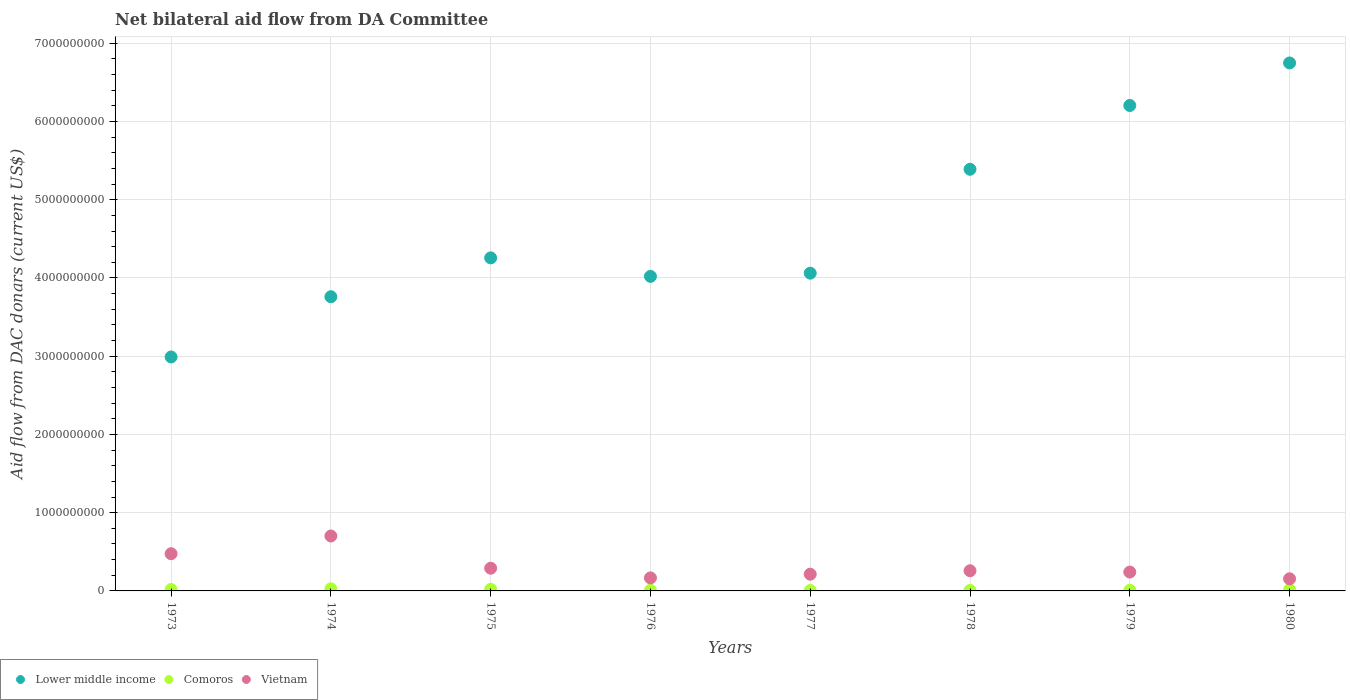How many different coloured dotlines are there?
Your response must be concise. 3. What is the aid flow in in Lower middle income in 1980?
Offer a terse response. 6.75e+09. Across all years, what is the maximum aid flow in in Vietnam?
Offer a very short reply. 7.02e+08. Across all years, what is the minimum aid flow in in Comoros?
Provide a succinct answer. 5.31e+06. In which year was the aid flow in in Vietnam maximum?
Make the answer very short. 1974. What is the total aid flow in in Vietnam in the graph?
Offer a very short reply. 2.50e+09. What is the difference between the aid flow in in Comoros in 1973 and that in 1974?
Your response must be concise. -9.69e+06. What is the difference between the aid flow in in Vietnam in 1973 and the aid flow in in Lower middle income in 1980?
Ensure brevity in your answer.  -6.27e+09. What is the average aid flow in in Vietnam per year?
Give a very brief answer. 3.13e+08. In the year 1976, what is the difference between the aid flow in in Vietnam and aid flow in in Lower middle income?
Provide a succinct answer. -3.85e+09. What is the ratio of the aid flow in in Lower middle income in 1973 to that in 1979?
Keep it short and to the point. 0.48. Is the difference between the aid flow in in Vietnam in 1975 and 1979 greater than the difference between the aid flow in in Lower middle income in 1975 and 1979?
Your answer should be very brief. Yes. What is the difference between the highest and the second highest aid flow in in Lower middle income?
Offer a very short reply. 5.44e+08. What is the difference between the highest and the lowest aid flow in in Comoros?
Make the answer very short. 2.19e+07. Is the sum of the aid flow in in Comoros in 1976 and 1977 greater than the maximum aid flow in in Lower middle income across all years?
Your response must be concise. No. Does the aid flow in in Lower middle income monotonically increase over the years?
Your answer should be compact. No. Is the aid flow in in Comoros strictly greater than the aid flow in in Vietnam over the years?
Provide a short and direct response. No. Is the aid flow in in Comoros strictly less than the aid flow in in Vietnam over the years?
Make the answer very short. Yes. How many dotlines are there?
Provide a short and direct response. 3. How many years are there in the graph?
Your response must be concise. 8. Are the values on the major ticks of Y-axis written in scientific E-notation?
Offer a terse response. No. Does the graph contain any zero values?
Make the answer very short. No. Does the graph contain grids?
Your answer should be compact. Yes. Where does the legend appear in the graph?
Offer a very short reply. Bottom left. How many legend labels are there?
Make the answer very short. 3. How are the legend labels stacked?
Make the answer very short. Horizontal. What is the title of the graph?
Provide a short and direct response. Net bilateral aid flow from DA Committee. What is the label or title of the X-axis?
Keep it short and to the point. Years. What is the label or title of the Y-axis?
Provide a short and direct response. Aid flow from DAC donars (current US$). What is the Aid flow from DAC donars (current US$) in Lower middle income in 1973?
Keep it short and to the point. 2.99e+09. What is the Aid flow from DAC donars (current US$) of Comoros in 1973?
Provide a succinct answer. 1.75e+07. What is the Aid flow from DAC donars (current US$) in Vietnam in 1973?
Offer a very short reply. 4.76e+08. What is the Aid flow from DAC donars (current US$) in Lower middle income in 1974?
Your answer should be compact. 3.76e+09. What is the Aid flow from DAC donars (current US$) in Comoros in 1974?
Offer a terse response. 2.72e+07. What is the Aid flow from DAC donars (current US$) of Vietnam in 1974?
Your answer should be very brief. 7.02e+08. What is the Aid flow from DAC donars (current US$) of Lower middle income in 1975?
Your response must be concise. 4.26e+09. What is the Aid flow from DAC donars (current US$) in Comoros in 1975?
Offer a very short reply. 2.10e+07. What is the Aid flow from DAC donars (current US$) of Vietnam in 1975?
Make the answer very short. 2.90e+08. What is the Aid flow from DAC donars (current US$) of Lower middle income in 1976?
Your response must be concise. 4.02e+09. What is the Aid flow from DAC donars (current US$) in Comoros in 1976?
Your answer should be compact. 9.35e+06. What is the Aid flow from DAC donars (current US$) in Vietnam in 1976?
Give a very brief answer. 1.67e+08. What is the Aid flow from DAC donars (current US$) of Lower middle income in 1977?
Your response must be concise. 4.06e+09. What is the Aid flow from DAC donars (current US$) of Comoros in 1977?
Your response must be concise. 5.31e+06. What is the Aid flow from DAC donars (current US$) of Vietnam in 1977?
Your answer should be very brief. 2.14e+08. What is the Aid flow from DAC donars (current US$) of Lower middle income in 1978?
Your response must be concise. 5.39e+09. What is the Aid flow from DAC donars (current US$) in Comoros in 1978?
Make the answer very short. 5.73e+06. What is the Aid flow from DAC donars (current US$) of Vietnam in 1978?
Ensure brevity in your answer.  2.58e+08. What is the Aid flow from DAC donars (current US$) in Lower middle income in 1979?
Make the answer very short. 6.20e+09. What is the Aid flow from DAC donars (current US$) of Comoros in 1979?
Provide a short and direct response. 8.47e+06. What is the Aid flow from DAC donars (current US$) in Vietnam in 1979?
Provide a short and direct response. 2.41e+08. What is the Aid flow from DAC donars (current US$) in Lower middle income in 1980?
Your answer should be very brief. 6.75e+09. What is the Aid flow from DAC donars (current US$) in Comoros in 1980?
Give a very brief answer. 1.65e+07. What is the Aid flow from DAC donars (current US$) of Vietnam in 1980?
Make the answer very short. 1.55e+08. Across all years, what is the maximum Aid flow from DAC donars (current US$) in Lower middle income?
Offer a very short reply. 6.75e+09. Across all years, what is the maximum Aid flow from DAC donars (current US$) of Comoros?
Provide a succinct answer. 2.72e+07. Across all years, what is the maximum Aid flow from DAC donars (current US$) in Vietnam?
Provide a succinct answer. 7.02e+08. Across all years, what is the minimum Aid flow from DAC donars (current US$) in Lower middle income?
Keep it short and to the point. 2.99e+09. Across all years, what is the minimum Aid flow from DAC donars (current US$) in Comoros?
Provide a short and direct response. 5.31e+06. Across all years, what is the minimum Aid flow from DAC donars (current US$) of Vietnam?
Your answer should be compact. 1.55e+08. What is the total Aid flow from DAC donars (current US$) of Lower middle income in the graph?
Keep it short and to the point. 3.74e+1. What is the total Aid flow from DAC donars (current US$) in Comoros in the graph?
Your answer should be compact. 1.11e+08. What is the total Aid flow from DAC donars (current US$) of Vietnam in the graph?
Keep it short and to the point. 2.50e+09. What is the difference between the Aid flow from DAC donars (current US$) in Lower middle income in 1973 and that in 1974?
Provide a succinct answer. -7.70e+08. What is the difference between the Aid flow from DAC donars (current US$) of Comoros in 1973 and that in 1974?
Provide a succinct answer. -9.69e+06. What is the difference between the Aid flow from DAC donars (current US$) of Vietnam in 1973 and that in 1974?
Give a very brief answer. -2.26e+08. What is the difference between the Aid flow from DAC donars (current US$) in Lower middle income in 1973 and that in 1975?
Make the answer very short. -1.27e+09. What is the difference between the Aid flow from DAC donars (current US$) of Comoros in 1973 and that in 1975?
Provide a short and direct response. -3.48e+06. What is the difference between the Aid flow from DAC donars (current US$) of Vietnam in 1973 and that in 1975?
Offer a terse response. 1.85e+08. What is the difference between the Aid flow from DAC donars (current US$) in Lower middle income in 1973 and that in 1976?
Ensure brevity in your answer.  -1.03e+09. What is the difference between the Aid flow from DAC donars (current US$) of Comoros in 1973 and that in 1976?
Give a very brief answer. 8.17e+06. What is the difference between the Aid flow from DAC donars (current US$) of Vietnam in 1973 and that in 1976?
Make the answer very short. 3.09e+08. What is the difference between the Aid flow from DAC donars (current US$) in Lower middle income in 1973 and that in 1977?
Your response must be concise. -1.07e+09. What is the difference between the Aid flow from DAC donars (current US$) in Comoros in 1973 and that in 1977?
Provide a succinct answer. 1.22e+07. What is the difference between the Aid flow from DAC donars (current US$) of Vietnam in 1973 and that in 1977?
Provide a succinct answer. 2.62e+08. What is the difference between the Aid flow from DAC donars (current US$) of Lower middle income in 1973 and that in 1978?
Give a very brief answer. -2.40e+09. What is the difference between the Aid flow from DAC donars (current US$) of Comoros in 1973 and that in 1978?
Your response must be concise. 1.18e+07. What is the difference between the Aid flow from DAC donars (current US$) in Vietnam in 1973 and that in 1978?
Provide a short and direct response. 2.18e+08. What is the difference between the Aid flow from DAC donars (current US$) in Lower middle income in 1973 and that in 1979?
Give a very brief answer. -3.21e+09. What is the difference between the Aid flow from DAC donars (current US$) of Comoros in 1973 and that in 1979?
Ensure brevity in your answer.  9.05e+06. What is the difference between the Aid flow from DAC donars (current US$) in Vietnam in 1973 and that in 1979?
Your answer should be very brief. 2.35e+08. What is the difference between the Aid flow from DAC donars (current US$) of Lower middle income in 1973 and that in 1980?
Keep it short and to the point. -3.76e+09. What is the difference between the Aid flow from DAC donars (current US$) in Comoros in 1973 and that in 1980?
Give a very brief answer. 1.04e+06. What is the difference between the Aid flow from DAC donars (current US$) of Vietnam in 1973 and that in 1980?
Your answer should be very brief. 3.21e+08. What is the difference between the Aid flow from DAC donars (current US$) in Lower middle income in 1974 and that in 1975?
Make the answer very short. -4.97e+08. What is the difference between the Aid flow from DAC donars (current US$) of Comoros in 1974 and that in 1975?
Give a very brief answer. 6.21e+06. What is the difference between the Aid flow from DAC donars (current US$) in Vietnam in 1974 and that in 1975?
Give a very brief answer. 4.12e+08. What is the difference between the Aid flow from DAC donars (current US$) in Lower middle income in 1974 and that in 1976?
Keep it short and to the point. -2.60e+08. What is the difference between the Aid flow from DAC donars (current US$) of Comoros in 1974 and that in 1976?
Provide a succinct answer. 1.79e+07. What is the difference between the Aid flow from DAC donars (current US$) in Vietnam in 1974 and that in 1976?
Ensure brevity in your answer.  5.36e+08. What is the difference between the Aid flow from DAC donars (current US$) of Lower middle income in 1974 and that in 1977?
Offer a very short reply. -3.01e+08. What is the difference between the Aid flow from DAC donars (current US$) of Comoros in 1974 and that in 1977?
Your answer should be very brief. 2.19e+07. What is the difference between the Aid flow from DAC donars (current US$) of Vietnam in 1974 and that in 1977?
Make the answer very short. 4.88e+08. What is the difference between the Aid flow from DAC donars (current US$) of Lower middle income in 1974 and that in 1978?
Your answer should be compact. -1.63e+09. What is the difference between the Aid flow from DAC donars (current US$) in Comoros in 1974 and that in 1978?
Your answer should be very brief. 2.15e+07. What is the difference between the Aid flow from DAC donars (current US$) in Vietnam in 1974 and that in 1978?
Keep it short and to the point. 4.44e+08. What is the difference between the Aid flow from DAC donars (current US$) in Lower middle income in 1974 and that in 1979?
Ensure brevity in your answer.  -2.44e+09. What is the difference between the Aid flow from DAC donars (current US$) in Comoros in 1974 and that in 1979?
Make the answer very short. 1.87e+07. What is the difference between the Aid flow from DAC donars (current US$) in Vietnam in 1974 and that in 1979?
Your answer should be very brief. 4.61e+08. What is the difference between the Aid flow from DAC donars (current US$) of Lower middle income in 1974 and that in 1980?
Give a very brief answer. -2.99e+09. What is the difference between the Aid flow from DAC donars (current US$) in Comoros in 1974 and that in 1980?
Ensure brevity in your answer.  1.07e+07. What is the difference between the Aid flow from DAC donars (current US$) of Vietnam in 1974 and that in 1980?
Ensure brevity in your answer.  5.47e+08. What is the difference between the Aid flow from DAC donars (current US$) in Lower middle income in 1975 and that in 1976?
Your response must be concise. 2.36e+08. What is the difference between the Aid flow from DAC donars (current US$) in Comoros in 1975 and that in 1976?
Your answer should be very brief. 1.16e+07. What is the difference between the Aid flow from DAC donars (current US$) in Vietnam in 1975 and that in 1976?
Offer a terse response. 1.24e+08. What is the difference between the Aid flow from DAC donars (current US$) in Lower middle income in 1975 and that in 1977?
Your response must be concise. 1.96e+08. What is the difference between the Aid flow from DAC donars (current US$) of Comoros in 1975 and that in 1977?
Your response must be concise. 1.57e+07. What is the difference between the Aid flow from DAC donars (current US$) of Vietnam in 1975 and that in 1977?
Offer a very short reply. 7.63e+07. What is the difference between the Aid flow from DAC donars (current US$) in Lower middle income in 1975 and that in 1978?
Your answer should be very brief. -1.13e+09. What is the difference between the Aid flow from DAC donars (current US$) of Comoros in 1975 and that in 1978?
Your answer should be compact. 1.53e+07. What is the difference between the Aid flow from DAC donars (current US$) in Vietnam in 1975 and that in 1978?
Keep it short and to the point. 3.23e+07. What is the difference between the Aid flow from DAC donars (current US$) of Lower middle income in 1975 and that in 1979?
Make the answer very short. -1.95e+09. What is the difference between the Aid flow from DAC donars (current US$) in Comoros in 1975 and that in 1979?
Provide a short and direct response. 1.25e+07. What is the difference between the Aid flow from DAC donars (current US$) of Vietnam in 1975 and that in 1979?
Your answer should be compact. 4.92e+07. What is the difference between the Aid flow from DAC donars (current US$) in Lower middle income in 1975 and that in 1980?
Your answer should be very brief. -2.49e+09. What is the difference between the Aid flow from DAC donars (current US$) of Comoros in 1975 and that in 1980?
Offer a terse response. 4.52e+06. What is the difference between the Aid flow from DAC donars (current US$) of Vietnam in 1975 and that in 1980?
Provide a succinct answer. 1.35e+08. What is the difference between the Aid flow from DAC donars (current US$) of Lower middle income in 1976 and that in 1977?
Your response must be concise. -4.10e+07. What is the difference between the Aid flow from DAC donars (current US$) in Comoros in 1976 and that in 1977?
Give a very brief answer. 4.04e+06. What is the difference between the Aid flow from DAC donars (current US$) of Vietnam in 1976 and that in 1977?
Offer a terse response. -4.73e+07. What is the difference between the Aid flow from DAC donars (current US$) in Lower middle income in 1976 and that in 1978?
Make the answer very short. -1.37e+09. What is the difference between the Aid flow from DAC donars (current US$) in Comoros in 1976 and that in 1978?
Offer a very short reply. 3.62e+06. What is the difference between the Aid flow from DAC donars (current US$) in Vietnam in 1976 and that in 1978?
Make the answer very short. -9.13e+07. What is the difference between the Aid flow from DAC donars (current US$) of Lower middle income in 1976 and that in 1979?
Offer a terse response. -2.18e+09. What is the difference between the Aid flow from DAC donars (current US$) in Comoros in 1976 and that in 1979?
Make the answer very short. 8.80e+05. What is the difference between the Aid flow from DAC donars (current US$) of Vietnam in 1976 and that in 1979?
Provide a succinct answer. -7.44e+07. What is the difference between the Aid flow from DAC donars (current US$) of Lower middle income in 1976 and that in 1980?
Make the answer very short. -2.73e+09. What is the difference between the Aid flow from DAC donars (current US$) of Comoros in 1976 and that in 1980?
Keep it short and to the point. -7.13e+06. What is the difference between the Aid flow from DAC donars (current US$) in Vietnam in 1976 and that in 1980?
Your answer should be very brief. 1.15e+07. What is the difference between the Aid flow from DAC donars (current US$) of Lower middle income in 1977 and that in 1978?
Your answer should be compact. -1.33e+09. What is the difference between the Aid flow from DAC donars (current US$) of Comoros in 1977 and that in 1978?
Offer a terse response. -4.20e+05. What is the difference between the Aid flow from DAC donars (current US$) in Vietnam in 1977 and that in 1978?
Your response must be concise. -4.40e+07. What is the difference between the Aid flow from DAC donars (current US$) of Lower middle income in 1977 and that in 1979?
Your answer should be very brief. -2.14e+09. What is the difference between the Aid flow from DAC donars (current US$) of Comoros in 1977 and that in 1979?
Offer a terse response. -3.16e+06. What is the difference between the Aid flow from DAC donars (current US$) of Vietnam in 1977 and that in 1979?
Make the answer very short. -2.71e+07. What is the difference between the Aid flow from DAC donars (current US$) of Lower middle income in 1977 and that in 1980?
Your answer should be very brief. -2.69e+09. What is the difference between the Aid flow from DAC donars (current US$) of Comoros in 1977 and that in 1980?
Make the answer very short. -1.12e+07. What is the difference between the Aid flow from DAC donars (current US$) in Vietnam in 1977 and that in 1980?
Ensure brevity in your answer.  5.88e+07. What is the difference between the Aid flow from DAC donars (current US$) of Lower middle income in 1978 and that in 1979?
Keep it short and to the point. -8.15e+08. What is the difference between the Aid flow from DAC donars (current US$) of Comoros in 1978 and that in 1979?
Keep it short and to the point. -2.74e+06. What is the difference between the Aid flow from DAC donars (current US$) in Vietnam in 1978 and that in 1979?
Your answer should be compact. 1.69e+07. What is the difference between the Aid flow from DAC donars (current US$) of Lower middle income in 1978 and that in 1980?
Your response must be concise. -1.36e+09. What is the difference between the Aid flow from DAC donars (current US$) in Comoros in 1978 and that in 1980?
Offer a very short reply. -1.08e+07. What is the difference between the Aid flow from DAC donars (current US$) of Vietnam in 1978 and that in 1980?
Ensure brevity in your answer.  1.03e+08. What is the difference between the Aid flow from DAC donars (current US$) of Lower middle income in 1979 and that in 1980?
Offer a very short reply. -5.44e+08. What is the difference between the Aid flow from DAC donars (current US$) in Comoros in 1979 and that in 1980?
Your answer should be very brief. -8.01e+06. What is the difference between the Aid flow from DAC donars (current US$) in Vietnam in 1979 and that in 1980?
Keep it short and to the point. 8.59e+07. What is the difference between the Aid flow from DAC donars (current US$) of Lower middle income in 1973 and the Aid flow from DAC donars (current US$) of Comoros in 1974?
Offer a terse response. 2.96e+09. What is the difference between the Aid flow from DAC donars (current US$) in Lower middle income in 1973 and the Aid flow from DAC donars (current US$) in Vietnam in 1974?
Provide a succinct answer. 2.29e+09. What is the difference between the Aid flow from DAC donars (current US$) of Comoros in 1973 and the Aid flow from DAC donars (current US$) of Vietnam in 1974?
Keep it short and to the point. -6.85e+08. What is the difference between the Aid flow from DAC donars (current US$) in Lower middle income in 1973 and the Aid flow from DAC donars (current US$) in Comoros in 1975?
Your answer should be compact. 2.97e+09. What is the difference between the Aid flow from DAC donars (current US$) in Lower middle income in 1973 and the Aid flow from DAC donars (current US$) in Vietnam in 1975?
Ensure brevity in your answer.  2.70e+09. What is the difference between the Aid flow from DAC donars (current US$) of Comoros in 1973 and the Aid flow from DAC donars (current US$) of Vietnam in 1975?
Ensure brevity in your answer.  -2.73e+08. What is the difference between the Aid flow from DAC donars (current US$) of Lower middle income in 1973 and the Aid flow from DAC donars (current US$) of Comoros in 1976?
Provide a succinct answer. 2.98e+09. What is the difference between the Aid flow from DAC donars (current US$) of Lower middle income in 1973 and the Aid flow from DAC donars (current US$) of Vietnam in 1976?
Ensure brevity in your answer.  2.82e+09. What is the difference between the Aid flow from DAC donars (current US$) in Comoros in 1973 and the Aid flow from DAC donars (current US$) in Vietnam in 1976?
Offer a very short reply. -1.49e+08. What is the difference between the Aid flow from DAC donars (current US$) of Lower middle income in 1973 and the Aid flow from DAC donars (current US$) of Comoros in 1977?
Your response must be concise. 2.98e+09. What is the difference between the Aid flow from DAC donars (current US$) of Lower middle income in 1973 and the Aid flow from DAC donars (current US$) of Vietnam in 1977?
Provide a succinct answer. 2.78e+09. What is the difference between the Aid flow from DAC donars (current US$) of Comoros in 1973 and the Aid flow from DAC donars (current US$) of Vietnam in 1977?
Provide a short and direct response. -1.96e+08. What is the difference between the Aid flow from DAC donars (current US$) of Lower middle income in 1973 and the Aid flow from DAC donars (current US$) of Comoros in 1978?
Offer a very short reply. 2.98e+09. What is the difference between the Aid flow from DAC donars (current US$) of Lower middle income in 1973 and the Aid flow from DAC donars (current US$) of Vietnam in 1978?
Ensure brevity in your answer.  2.73e+09. What is the difference between the Aid flow from DAC donars (current US$) in Comoros in 1973 and the Aid flow from DAC donars (current US$) in Vietnam in 1978?
Offer a very short reply. -2.40e+08. What is the difference between the Aid flow from DAC donars (current US$) of Lower middle income in 1973 and the Aid flow from DAC donars (current US$) of Comoros in 1979?
Your answer should be very brief. 2.98e+09. What is the difference between the Aid flow from DAC donars (current US$) in Lower middle income in 1973 and the Aid flow from DAC donars (current US$) in Vietnam in 1979?
Your answer should be very brief. 2.75e+09. What is the difference between the Aid flow from DAC donars (current US$) in Comoros in 1973 and the Aid flow from DAC donars (current US$) in Vietnam in 1979?
Your answer should be very brief. -2.23e+08. What is the difference between the Aid flow from DAC donars (current US$) in Lower middle income in 1973 and the Aid flow from DAC donars (current US$) in Comoros in 1980?
Make the answer very short. 2.97e+09. What is the difference between the Aid flow from DAC donars (current US$) of Lower middle income in 1973 and the Aid flow from DAC donars (current US$) of Vietnam in 1980?
Give a very brief answer. 2.84e+09. What is the difference between the Aid flow from DAC donars (current US$) in Comoros in 1973 and the Aid flow from DAC donars (current US$) in Vietnam in 1980?
Your answer should be compact. -1.38e+08. What is the difference between the Aid flow from DAC donars (current US$) in Lower middle income in 1974 and the Aid flow from DAC donars (current US$) in Comoros in 1975?
Your response must be concise. 3.74e+09. What is the difference between the Aid flow from DAC donars (current US$) of Lower middle income in 1974 and the Aid flow from DAC donars (current US$) of Vietnam in 1975?
Make the answer very short. 3.47e+09. What is the difference between the Aid flow from DAC donars (current US$) in Comoros in 1974 and the Aid flow from DAC donars (current US$) in Vietnam in 1975?
Keep it short and to the point. -2.63e+08. What is the difference between the Aid flow from DAC donars (current US$) in Lower middle income in 1974 and the Aid flow from DAC donars (current US$) in Comoros in 1976?
Offer a terse response. 3.75e+09. What is the difference between the Aid flow from DAC donars (current US$) of Lower middle income in 1974 and the Aid flow from DAC donars (current US$) of Vietnam in 1976?
Offer a very short reply. 3.59e+09. What is the difference between the Aid flow from DAC donars (current US$) in Comoros in 1974 and the Aid flow from DAC donars (current US$) in Vietnam in 1976?
Ensure brevity in your answer.  -1.39e+08. What is the difference between the Aid flow from DAC donars (current US$) of Lower middle income in 1974 and the Aid flow from DAC donars (current US$) of Comoros in 1977?
Your answer should be compact. 3.75e+09. What is the difference between the Aid flow from DAC donars (current US$) of Lower middle income in 1974 and the Aid flow from DAC donars (current US$) of Vietnam in 1977?
Provide a short and direct response. 3.55e+09. What is the difference between the Aid flow from DAC donars (current US$) in Comoros in 1974 and the Aid flow from DAC donars (current US$) in Vietnam in 1977?
Provide a short and direct response. -1.87e+08. What is the difference between the Aid flow from DAC donars (current US$) in Lower middle income in 1974 and the Aid flow from DAC donars (current US$) in Comoros in 1978?
Make the answer very short. 3.75e+09. What is the difference between the Aid flow from DAC donars (current US$) of Lower middle income in 1974 and the Aid flow from DAC donars (current US$) of Vietnam in 1978?
Keep it short and to the point. 3.50e+09. What is the difference between the Aid flow from DAC donars (current US$) of Comoros in 1974 and the Aid flow from DAC donars (current US$) of Vietnam in 1978?
Your answer should be compact. -2.31e+08. What is the difference between the Aid flow from DAC donars (current US$) in Lower middle income in 1974 and the Aid flow from DAC donars (current US$) in Comoros in 1979?
Your response must be concise. 3.75e+09. What is the difference between the Aid flow from DAC donars (current US$) in Lower middle income in 1974 and the Aid flow from DAC donars (current US$) in Vietnam in 1979?
Your answer should be very brief. 3.52e+09. What is the difference between the Aid flow from DAC donars (current US$) of Comoros in 1974 and the Aid flow from DAC donars (current US$) of Vietnam in 1979?
Keep it short and to the point. -2.14e+08. What is the difference between the Aid flow from DAC donars (current US$) of Lower middle income in 1974 and the Aid flow from DAC donars (current US$) of Comoros in 1980?
Ensure brevity in your answer.  3.74e+09. What is the difference between the Aid flow from DAC donars (current US$) of Lower middle income in 1974 and the Aid flow from DAC donars (current US$) of Vietnam in 1980?
Ensure brevity in your answer.  3.60e+09. What is the difference between the Aid flow from DAC donars (current US$) in Comoros in 1974 and the Aid flow from DAC donars (current US$) in Vietnam in 1980?
Ensure brevity in your answer.  -1.28e+08. What is the difference between the Aid flow from DAC donars (current US$) of Lower middle income in 1975 and the Aid flow from DAC donars (current US$) of Comoros in 1976?
Provide a succinct answer. 4.25e+09. What is the difference between the Aid flow from DAC donars (current US$) of Lower middle income in 1975 and the Aid flow from DAC donars (current US$) of Vietnam in 1976?
Provide a succinct answer. 4.09e+09. What is the difference between the Aid flow from DAC donars (current US$) of Comoros in 1975 and the Aid flow from DAC donars (current US$) of Vietnam in 1976?
Your answer should be very brief. -1.46e+08. What is the difference between the Aid flow from DAC donars (current US$) of Lower middle income in 1975 and the Aid flow from DAC donars (current US$) of Comoros in 1977?
Ensure brevity in your answer.  4.25e+09. What is the difference between the Aid flow from DAC donars (current US$) in Lower middle income in 1975 and the Aid flow from DAC donars (current US$) in Vietnam in 1977?
Offer a very short reply. 4.04e+09. What is the difference between the Aid flow from DAC donars (current US$) in Comoros in 1975 and the Aid flow from DAC donars (current US$) in Vietnam in 1977?
Your response must be concise. -1.93e+08. What is the difference between the Aid flow from DAC donars (current US$) of Lower middle income in 1975 and the Aid flow from DAC donars (current US$) of Comoros in 1978?
Offer a very short reply. 4.25e+09. What is the difference between the Aid flow from DAC donars (current US$) of Lower middle income in 1975 and the Aid flow from DAC donars (current US$) of Vietnam in 1978?
Give a very brief answer. 4.00e+09. What is the difference between the Aid flow from DAC donars (current US$) in Comoros in 1975 and the Aid flow from DAC donars (current US$) in Vietnam in 1978?
Provide a succinct answer. -2.37e+08. What is the difference between the Aid flow from DAC donars (current US$) of Lower middle income in 1975 and the Aid flow from DAC donars (current US$) of Comoros in 1979?
Make the answer very short. 4.25e+09. What is the difference between the Aid flow from DAC donars (current US$) in Lower middle income in 1975 and the Aid flow from DAC donars (current US$) in Vietnam in 1979?
Offer a terse response. 4.02e+09. What is the difference between the Aid flow from DAC donars (current US$) in Comoros in 1975 and the Aid flow from DAC donars (current US$) in Vietnam in 1979?
Provide a succinct answer. -2.20e+08. What is the difference between the Aid flow from DAC donars (current US$) in Lower middle income in 1975 and the Aid flow from DAC donars (current US$) in Comoros in 1980?
Make the answer very short. 4.24e+09. What is the difference between the Aid flow from DAC donars (current US$) of Lower middle income in 1975 and the Aid flow from DAC donars (current US$) of Vietnam in 1980?
Offer a very short reply. 4.10e+09. What is the difference between the Aid flow from DAC donars (current US$) of Comoros in 1975 and the Aid flow from DAC donars (current US$) of Vietnam in 1980?
Offer a terse response. -1.34e+08. What is the difference between the Aid flow from DAC donars (current US$) in Lower middle income in 1976 and the Aid flow from DAC donars (current US$) in Comoros in 1977?
Provide a succinct answer. 4.01e+09. What is the difference between the Aid flow from DAC donars (current US$) in Lower middle income in 1976 and the Aid flow from DAC donars (current US$) in Vietnam in 1977?
Provide a succinct answer. 3.81e+09. What is the difference between the Aid flow from DAC donars (current US$) of Comoros in 1976 and the Aid flow from DAC donars (current US$) of Vietnam in 1977?
Give a very brief answer. -2.05e+08. What is the difference between the Aid flow from DAC donars (current US$) in Lower middle income in 1976 and the Aid flow from DAC donars (current US$) in Comoros in 1978?
Provide a short and direct response. 4.01e+09. What is the difference between the Aid flow from DAC donars (current US$) of Lower middle income in 1976 and the Aid flow from DAC donars (current US$) of Vietnam in 1978?
Give a very brief answer. 3.76e+09. What is the difference between the Aid flow from DAC donars (current US$) in Comoros in 1976 and the Aid flow from DAC donars (current US$) in Vietnam in 1978?
Ensure brevity in your answer.  -2.49e+08. What is the difference between the Aid flow from DAC donars (current US$) in Lower middle income in 1976 and the Aid flow from DAC donars (current US$) in Comoros in 1979?
Provide a succinct answer. 4.01e+09. What is the difference between the Aid flow from DAC donars (current US$) of Lower middle income in 1976 and the Aid flow from DAC donars (current US$) of Vietnam in 1979?
Provide a succinct answer. 3.78e+09. What is the difference between the Aid flow from DAC donars (current US$) in Comoros in 1976 and the Aid flow from DAC donars (current US$) in Vietnam in 1979?
Keep it short and to the point. -2.32e+08. What is the difference between the Aid flow from DAC donars (current US$) in Lower middle income in 1976 and the Aid flow from DAC donars (current US$) in Comoros in 1980?
Make the answer very short. 4.00e+09. What is the difference between the Aid flow from DAC donars (current US$) of Lower middle income in 1976 and the Aid flow from DAC donars (current US$) of Vietnam in 1980?
Keep it short and to the point. 3.86e+09. What is the difference between the Aid flow from DAC donars (current US$) of Comoros in 1976 and the Aid flow from DAC donars (current US$) of Vietnam in 1980?
Your answer should be compact. -1.46e+08. What is the difference between the Aid flow from DAC donars (current US$) in Lower middle income in 1977 and the Aid flow from DAC donars (current US$) in Comoros in 1978?
Your answer should be very brief. 4.06e+09. What is the difference between the Aid flow from DAC donars (current US$) in Lower middle income in 1977 and the Aid flow from DAC donars (current US$) in Vietnam in 1978?
Provide a short and direct response. 3.80e+09. What is the difference between the Aid flow from DAC donars (current US$) in Comoros in 1977 and the Aid flow from DAC donars (current US$) in Vietnam in 1978?
Keep it short and to the point. -2.53e+08. What is the difference between the Aid flow from DAC donars (current US$) of Lower middle income in 1977 and the Aid flow from DAC donars (current US$) of Comoros in 1979?
Offer a very short reply. 4.05e+09. What is the difference between the Aid flow from DAC donars (current US$) of Lower middle income in 1977 and the Aid flow from DAC donars (current US$) of Vietnam in 1979?
Make the answer very short. 3.82e+09. What is the difference between the Aid flow from DAC donars (current US$) of Comoros in 1977 and the Aid flow from DAC donars (current US$) of Vietnam in 1979?
Your answer should be very brief. -2.36e+08. What is the difference between the Aid flow from DAC donars (current US$) of Lower middle income in 1977 and the Aid flow from DAC donars (current US$) of Comoros in 1980?
Give a very brief answer. 4.04e+09. What is the difference between the Aid flow from DAC donars (current US$) of Lower middle income in 1977 and the Aid flow from DAC donars (current US$) of Vietnam in 1980?
Your response must be concise. 3.91e+09. What is the difference between the Aid flow from DAC donars (current US$) in Comoros in 1977 and the Aid flow from DAC donars (current US$) in Vietnam in 1980?
Your answer should be compact. -1.50e+08. What is the difference between the Aid flow from DAC donars (current US$) in Lower middle income in 1978 and the Aid flow from DAC donars (current US$) in Comoros in 1979?
Your response must be concise. 5.38e+09. What is the difference between the Aid flow from DAC donars (current US$) of Lower middle income in 1978 and the Aid flow from DAC donars (current US$) of Vietnam in 1979?
Your answer should be compact. 5.15e+09. What is the difference between the Aid flow from DAC donars (current US$) of Comoros in 1978 and the Aid flow from DAC donars (current US$) of Vietnam in 1979?
Provide a short and direct response. -2.35e+08. What is the difference between the Aid flow from DAC donars (current US$) of Lower middle income in 1978 and the Aid flow from DAC donars (current US$) of Comoros in 1980?
Provide a succinct answer. 5.37e+09. What is the difference between the Aid flow from DAC donars (current US$) of Lower middle income in 1978 and the Aid flow from DAC donars (current US$) of Vietnam in 1980?
Your response must be concise. 5.23e+09. What is the difference between the Aid flow from DAC donars (current US$) in Comoros in 1978 and the Aid flow from DAC donars (current US$) in Vietnam in 1980?
Your response must be concise. -1.49e+08. What is the difference between the Aid flow from DAC donars (current US$) of Lower middle income in 1979 and the Aid flow from DAC donars (current US$) of Comoros in 1980?
Give a very brief answer. 6.19e+09. What is the difference between the Aid flow from DAC donars (current US$) in Lower middle income in 1979 and the Aid flow from DAC donars (current US$) in Vietnam in 1980?
Give a very brief answer. 6.05e+09. What is the difference between the Aid flow from DAC donars (current US$) of Comoros in 1979 and the Aid flow from DAC donars (current US$) of Vietnam in 1980?
Make the answer very short. -1.47e+08. What is the average Aid flow from DAC donars (current US$) of Lower middle income per year?
Your answer should be compact. 4.68e+09. What is the average Aid flow from DAC donars (current US$) in Comoros per year?
Offer a very short reply. 1.39e+07. What is the average Aid flow from DAC donars (current US$) of Vietnam per year?
Provide a short and direct response. 3.13e+08. In the year 1973, what is the difference between the Aid flow from DAC donars (current US$) of Lower middle income and Aid flow from DAC donars (current US$) of Comoros?
Your answer should be compact. 2.97e+09. In the year 1973, what is the difference between the Aid flow from DAC donars (current US$) in Lower middle income and Aid flow from DAC donars (current US$) in Vietnam?
Make the answer very short. 2.51e+09. In the year 1973, what is the difference between the Aid flow from DAC donars (current US$) of Comoros and Aid flow from DAC donars (current US$) of Vietnam?
Give a very brief answer. -4.58e+08. In the year 1974, what is the difference between the Aid flow from DAC donars (current US$) in Lower middle income and Aid flow from DAC donars (current US$) in Comoros?
Keep it short and to the point. 3.73e+09. In the year 1974, what is the difference between the Aid flow from DAC donars (current US$) of Lower middle income and Aid flow from DAC donars (current US$) of Vietnam?
Provide a short and direct response. 3.06e+09. In the year 1974, what is the difference between the Aid flow from DAC donars (current US$) of Comoros and Aid flow from DAC donars (current US$) of Vietnam?
Ensure brevity in your answer.  -6.75e+08. In the year 1975, what is the difference between the Aid flow from DAC donars (current US$) of Lower middle income and Aid flow from DAC donars (current US$) of Comoros?
Your answer should be very brief. 4.24e+09. In the year 1975, what is the difference between the Aid flow from DAC donars (current US$) in Lower middle income and Aid flow from DAC donars (current US$) in Vietnam?
Keep it short and to the point. 3.97e+09. In the year 1975, what is the difference between the Aid flow from DAC donars (current US$) of Comoros and Aid flow from DAC donars (current US$) of Vietnam?
Keep it short and to the point. -2.69e+08. In the year 1976, what is the difference between the Aid flow from DAC donars (current US$) of Lower middle income and Aid flow from DAC donars (current US$) of Comoros?
Give a very brief answer. 4.01e+09. In the year 1976, what is the difference between the Aid flow from DAC donars (current US$) of Lower middle income and Aid flow from DAC donars (current US$) of Vietnam?
Keep it short and to the point. 3.85e+09. In the year 1976, what is the difference between the Aid flow from DAC donars (current US$) in Comoros and Aid flow from DAC donars (current US$) in Vietnam?
Make the answer very short. -1.57e+08. In the year 1977, what is the difference between the Aid flow from DAC donars (current US$) of Lower middle income and Aid flow from DAC donars (current US$) of Comoros?
Your response must be concise. 4.06e+09. In the year 1977, what is the difference between the Aid flow from DAC donars (current US$) of Lower middle income and Aid flow from DAC donars (current US$) of Vietnam?
Your answer should be very brief. 3.85e+09. In the year 1977, what is the difference between the Aid flow from DAC donars (current US$) in Comoros and Aid flow from DAC donars (current US$) in Vietnam?
Ensure brevity in your answer.  -2.09e+08. In the year 1978, what is the difference between the Aid flow from DAC donars (current US$) in Lower middle income and Aid flow from DAC donars (current US$) in Comoros?
Your answer should be very brief. 5.38e+09. In the year 1978, what is the difference between the Aid flow from DAC donars (current US$) of Lower middle income and Aid flow from DAC donars (current US$) of Vietnam?
Your answer should be very brief. 5.13e+09. In the year 1978, what is the difference between the Aid flow from DAC donars (current US$) in Comoros and Aid flow from DAC donars (current US$) in Vietnam?
Make the answer very short. -2.52e+08. In the year 1979, what is the difference between the Aid flow from DAC donars (current US$) in Lower middle income and Aid flow from DAC donars (current US$) in Comoros?
Make the answer very short. 6.20e+09. In the year 1979, what is the difference between the Aid flow from DAC donars (current US$) in Lower middle income and Aid flow from DAC donars (current US$) in Vietnam?
Keep it short and to the point. 5.96e+09. In the year 1979, what is the difference between the Aid flow from DAC donars (current US$) of Comoros and Aid flow from DAC donars (current US$) of Vietnam?
Provide a succinct answer. -2.33e+08. In the year 1980, what is the difference between the Aid flow from DAC donars (current US$) in Lower middle income and Aid flow from DAC donars (current US$) in Comoros?
Make the answer very short. 6.73e+09. In the year 1980, what is the difference between the Aid flow from DAC donars (current US$) in Lower middle income and Aid flow from DAC donars (current US$) in Vietnam?
Your answer should be compact. 6.59e+09. In the year 1980, what is the difference between the Aid flow from DAC donars (current US$) of Comoros and Aid flow from DAC donars (current US$) of Vietnam?
Give a very brief answer. -1.39e+08. What is the ratio of the Aid flow from DAC donars (current US$) of Lower middle income in 1973 to that in 1974?
Keep it short and to the point. 0.8. What is the ratio of the Aid flow from DAC donars (current US$) in Comoros in 1973 to that in 1974?
Your answer should be compact. 0.64. What is the ratio of the Aid flow from DAC donars (current US$) in Vietnam in 1973 to that in 1974?
Your answer should be compact. 0.68. What is the ratio of the Aid flow from DAC donars (current US$) in Lower middle income in 1973 to that in 1975?
Keep it short and to the point. 0.7. What is the ratio of the Aid flow from DAC donars (current US$) of Comoros in 1973 to that in 1975?
Provide a succinct answer. 0.83. What is the ratio of the Aid flow from DAC donars (current US$) of Vietnam in 1973 to that in 1975?
Give a very brief answer. 1.64. What is the ratio of the Aid flow from DAC donars (current US$) of Lower middle income in 1973 to that in 1976?
Ensure brevity in your answer.  0.74. What is the ratio of the Aid flow from DAC donars (current US$) in Comoros in 1973 to that in 1976?
Offer a terse response. 1.87. What is the ratio of the Aid flow from DAC donars (current US$) in Vietnam in 1973 to that in 1976?
Your answer should be very brief. 2.86. What is the ratio of the Aid flow from DAC donars (current US$) in Lower middle income in 1973 to that in 1977?
Give a very brief answer. 0.74. What is the ratio of the Aid flow from DAC donars (current US$) of Comoros in 1973 to that in 1977?
Provide a succinct answer. 3.3. What is the ratio of the Aid flow from DAC donars (current US$) in Vietnam in 1973 to that in 1977?
Your answer should be compact. 2.22. What is the ratio of the Aid flow from DAC donars (current US$) in Lower middle income in 1973 to that in 1978?
Your response must be concise. 0.55. What is the ratio of the Aid flow from DAC donars (current US$) of Comoros in 1973 to that in 1978?
Offer a terse response. 3.06. What is the ratio of the Aid flow from DAC donars (current US$) of Vietnam in 1973 to that in 1978?
Give a very brief answer. 1.84. What is the ratio of the Aid flow from DAC donars (current US$) in Lower middle income in 1973 to that in 1979?
Offer a terse response. 0.48. What is the ratio of the Aid flow from DAC donars (current US$) of Comoros in 1973 to that in 1979?
Give a very brief answer. 2.07. What is the ratio of the Aid flow from DAC donars (current US$) in Vietnam in 1973 to that in 1979?
Offer a very short reply. 1.97. What is the ratio of the Aid flow from DAC donars (current US$) in Lower middle income in 1973 to that in 1980?
Keep it short and to the point. 0.44. What is the ratio of the Aid flow from DAC donars (current US$) in Comoros in 1973 to that in 1980?
Give a very brief answer. 1.06. What is the ratio of the Aid flow from DAC donars (current US$) of Vietnam in 1973 to that in 1980?
Your response must be concise. 3.07. What is the ratio of the Aid flow from DAC donars (current US$) in Lower middle income in 1974 to that in 1975?
Ensure brevity in your answer.  0.88. What is the ratio of the Aid flow from DAC donars (current US$) of Comoros in 1974 to that in 1975?
Ensure brevity in your answer.  1.3. What is the ratio of the Aid flow from DAC donars (current US$) of Vietnam in 1974 to that in 1975?
Your response must be concise. 2.42. What is the ratio of the Aid flow from DAC donars (current US$) of Lower middle income in 1974 to that in 1976?
Your answer should be compact. 0.94. What is the ratio of the Aid flow from DAC donars (current US$) of Comoros in 1974 to that in 1976?
Make the answer very short. 2.91. What is the ratio of the Aid flow from DAC donars (current US$) of Vietnam in 1974 to that in 1976?
Offer a very short reply. 4.21. What is the ratio of the Aid flow from DAC donars (current US$) in Lower middle income in 1974 to that in 1977?
Offer a very short reply. 0.93. What is the ratio of the Aid flow from DAC donars (current US$) of Comoros in 1974 to that in 1977?
Provide a succinct answer. 5.12. What is the ratio of the Aid flow from DAC donars (current US$) in Vietnam in 1974 to that in 1977?
Your answer should be compact. 3.28. What is the ratio of the Aid flow from DAC donars (current US$) in Lower middle income in 1974 to that in 1978?
Make the answer very short. 0.7. What is the ratio of the Aid flow from DAC donars (current US$) of Comoros in 1974 to that in 1978?
Your response must be concise. 4.75. What is the ratio of the Aid flow from DAC donars (current US$) in Vietnam in 1974 to that in 1978?
Your answer should be compact. 2.72. What is the ratio of the Aid flow from DAC donars (current US$) in Lower middle income in 1974 to that in 1979?
Your answer should be very brief. 0.61. What is the ratio of the Aid flow from DAC donars (current US$) in Comoros in 1974 to that in 1979?
Your answer should be compact. 3.21. What is the ratio of the Aid flow from DAC donars (current US$) in Vietnam in 1974 to that in 1979?
Your response must be concise. 2.91. What is the ratio of the Aid flow from DAC donars (current US$) in Lower middle income in 1974 to that in 1980?
Keep it short and to the point. 0.56. What is the ratio of the Aid flow from DAC donars (current US$) in Comoros in 1974 to that in 1980?
Keep it short and to the point. 1.65. What is the ratio of the Aid flow from DAC donars (current US$) in Vietnam in 1974 to that in 1980?
Your response must be concise. 4.53. What is the ratio of the Aid flow from DAC donars (current US$) in Lower middle income in 1975 to that in 1976?
Keep it short and to the point. 1.06. What is the ratio of the Aid flow from DAC donars (current US$) in Comoros in 1975 to that in 1976?
Your answer should be compact. 2.25. What is the ratio of the Aid flow from DAC donars (current US$) in Vietnam in 1975 to that in 1976?
Provide a short and direct response. 1.74. What is the ratio of the Aid flow from DAC donars (current US$) in Lower middle income in 1975 to that in 1977?
Offer a terse response. 1.05. What is the ratio of the Aid flow from DAC donars (current US$) in Comoros in 1975 to that in 1977?
Offer a very short reply. 3.95. What is the ratio of the Aid flow from DAC donars (current US$) in Vietnam in 1975 to that in 1977?
Provide a succinct answer. 1.36. What is the ratio of the Aid flow from DAC donars (current US$) in Lower middle income in 1975 to that in 1978?
Your answer should be very brief. 0.79. What is the ratio of the Aid flow from DAC donars (current US$) in Comoros in 1975 to that in 1978?
Your answer should be compact. 3.66. What is the ratio of the Aid flow from DAC donars (current US$) of Vietnam in 1975 to that in 1978?
Provide a short and direct response. 1.13. What is the ratio of the Aid flow from DAC donars (current US$) of Lower middle income in 1975 to that in 1979?
Provide a succinct answer. 0.69. What is the ratio of the Aid flow from DAC donars (current US$) of Comoros in 1975 to that in 1979?
Your response must be concise. 2.48. What is the ratio of the Aid flow from DAC donars (current US$) in Vietnam in 1975 to that in 1979?
Provide a succinct answer. 1.2. What is the ratio of the Aid flow from DAC donars (current US$) of Lower middle income in 1975 to that in 1980?
Give a very brief answer. 0.63. What is the ratio of the Aid flow from DAC donars (current US$) in Comoros in 1975 to that in 1980?
Your answer should be compact. 1.27. What is the ratio of the Aid flow from DAC donars (current US$) of Vietnam in 1975 to that in 1980?
Give a very brief answer. 1.87. What is the ratio of the Aid flow from DAC donars (current US$) in Comoros in 1976 to that in 1977?
Your answer should be compact. 1.76. What is the ratio of the Aid flow from DAC donars (current US$) in Vietnam in 1976 to that in 1977?
Provide a short and direct response. 0.78. What is the ratio of the Aid flow from DAC donars (current US$) in Lower middle income in 1976 to that in 1978?
Provide a succinct answer. 0.75. What is the ratio of the Aid flow from DAC donars (current US$) of Comoros in 1976 to that in 1978?
Provide a short and direct response. 1.63. What is the ratio of the Aid flow from DAC donars (current US$) of Vietnam in 1976 to that in 1978?
Offer a terse response. 0.65. What is the ratio of the Aid flow from DAC donars (current US$) of Lower middle income in 1976 to that in 1979?
Keep it short and to the point. 0.65. What is the ratio of the Aid flow from DAC donars (current US$) of Comoros in 1976 to that in 1979?
Provide a succinct answer. 1.1. What is the ratio of the Aid flow from DAC donars (current US$) of Vietnam in 1976 to that in 1979?
Ensure brevity in your answer.  0.69. What is the ratio of the Aid flow from DAC donars (current US$) of Lower middle income in 1976 to that in 1980?
Provide a short and direct response. 0.6. What is the ratio of the Aid flow from DAC donars (current US$) in Comoros in 1976 to that in 1980?
Your answer should be compact. 0.57. What is the ratio of the Aid flow from DAC donars (current US$) in Vietnam in 1976 to that in 1980?
Provide a succinct answer. 1.07. What is the ratio of the Aid flow from DAC donars (current US$) in Lower middle income in 1977 to that in 1978?
Provide a succinct answer. 0.75. What is the ratio of the Aid flow from DAC donars (current US$) in Comoros in 1977 to that in 1978?
Offer a very short reply. 0.93. What is the ratio of the Aid flow from DAC donars (current US$) of Vietnam in 1977 to that in 1978?
Keep it short and to the point. 0.83. What is the ratio of the Aid flow from DAC donars (current US$) in Lower middle income in 1977 to that in 1979?
Provide a short and direct response. 0.65. What is the ratio of the Aid flow from DAC donars (current US$) of Comoros in 1977 to that in 1979?
Make the answer very short. 0.63. What is the ratio of the Aid flow from DAC donars (current US$) in Vietnam in 1977 to that in 1979?
Ensure brevity in your answer.  0.89. What is the ratio of the Aid flow from DAC donars (current US$) in Lower middle income in 1977 to that in 1980?
Make the answer very short. 0.6. What is the ratio of the Aid flow from DAC donars (current US$) of Comoros in 1977 to that in 1980?
Offer a terse response. 0.32. What is the ratio of the Aid flow from DAC donars (current US$) in Vietnam in 1977 to that in 1980?
Keep it short and to the point. 1.38. What is the ratio of the Aid flow from DAC donars (current US$) of Lower middle income in 1978 to that in 1979?
Make the answer very short. 0.87. What is the ratio of the Aid flow from DAC donars (current US$) in Comoros in 1978 to that in 1979?
Offer a terse response. 0.68. What is the ratio of the Aid flow from DAC donars (current US$) of Vietnam in 1978 to that in 1979?
Give a very brief answer. 1.07. What is the ratio of the Aid flow from DAC donars (current US$) of Lower middle income in 1978 to that in 1980?
Ensure brevity in your answer.  0.8. What is the ratio of the Aid flow from DAC donars (current US$) of Comoros in 1978 to that in 1980?
Your response must be concise. 0.35. What is the ratio of the Aid flow from DAC donars (current US$) of Vietnam in 1978 to that in 1980?
Provide a succinct answer. 1.66. What is the ratio of the Aid flow from DAC donars (current US$) of Lower middle income in 1979 to that in 1980?
Your answer should be compact. 0.92. What is the ratio of the Aid flow from DAC donars (current US$) of Comoros in 1979 to that in 1980?
Make the answer very short. 0.51. What is the ratio of the Aid flow from DAC donars (current US$) in Vietnam in 1979 to that in 1980?
Provide a short and direct response. 1.55. What is the difference between the highest and the second highest Aid flow from DAC donars (current US$) of Lower middle income?
Your answer should be very brief. 5.44e+08. What is the difference between the highest and the second highest Aid flow from DAC donars (current US$) in Comoros?
Your response must be concise. 6.21e+06. What is the difference between the highest and the second highest Aid flow from DAC donars (current US$) in Vietnam?
Keep it short and to the point. 2.26e+08. What is the difference between the highest and the lowest Aid flow from DAC donars (current US$) in Lower middle income?
Keep it short and to the point. 3.76e+09. What is the difference between the highest and the lowest Aid flow from DAC donars (current US$) in Comoros?
Keep it short and to the point. 2.19e+07. What is the difference between the highest and the lowest Aid flow from DAC donars (current US$) of Vietnam?
Keep it short and to the point. 5.47e+08. 